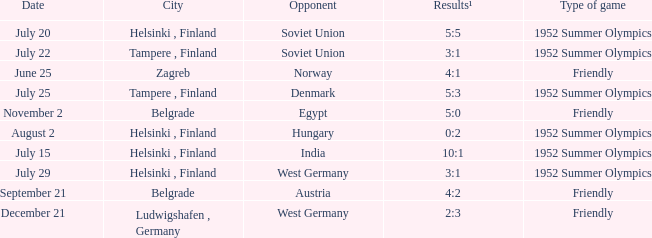What is the name of the municipality with december 21 as a date? Ludwigshafen , Germany. 